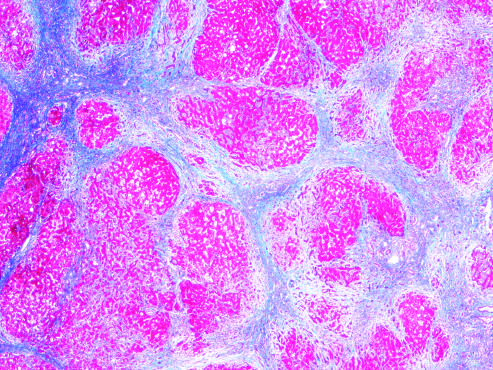when are most scars gone masson trichrome stain?
Answer the question using a single word or phrase. After 1 year of abstinence 